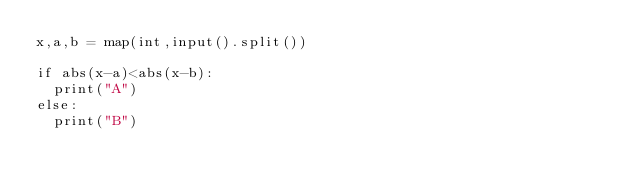Convert code to text. <code><loc_0><loc_0><loc_500><loc_500><_Python_>x,a,b = map(int,input().split())

if abs(x-a)<abs(x-b):
  print("A")
else:
  print("B")</code> 